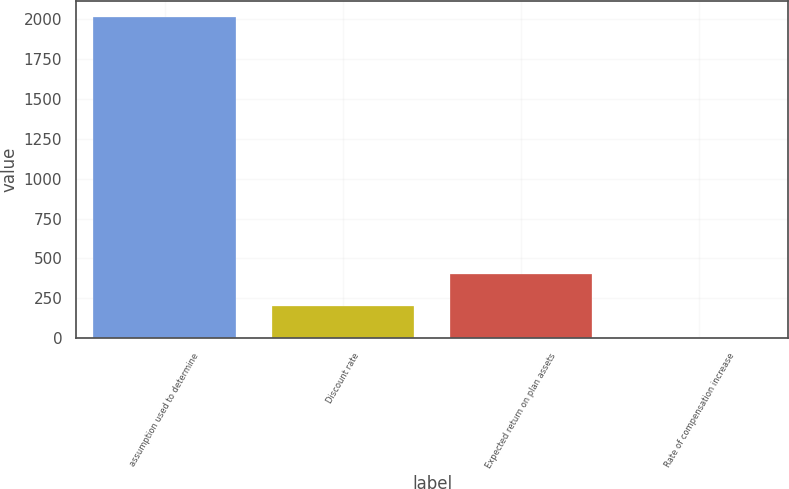Convert chart. <chart><loc_0><loc_0><loc_500><loc_500><bar_chart><fcel>assumption used to determine<fcel>Discount rate<fcel>Expected return on plan assets<fcel>Rate of compensation increase<nl><fcel>2013<fcel>204.23<fcel>405.21<fcel>3.25<nl></chart> 